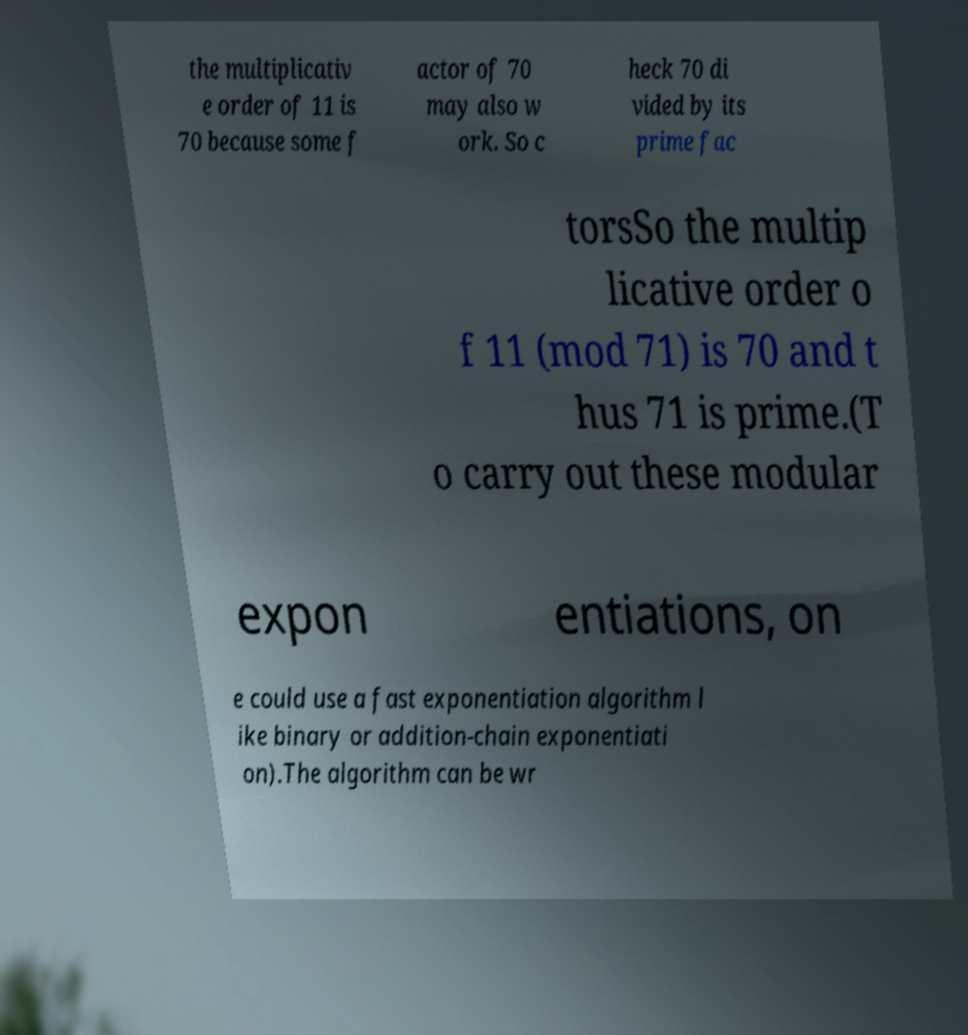There's text embedded in this image that I need extracted. Can you transcribe it verbatim? the multiplicativ e order of 11 is 70 because some f actor of 70 may also w ork. So c heck 70 di vided by its prime fac torsSo the multip licative order o f 11 (mod 71) is 70 and t hus 71 is prime.(T o carry out these modular expon entiations, on e could use a fast exponentiation algorithm l ike binary or addition-chain exponentiati on).The algorithm can be wr 